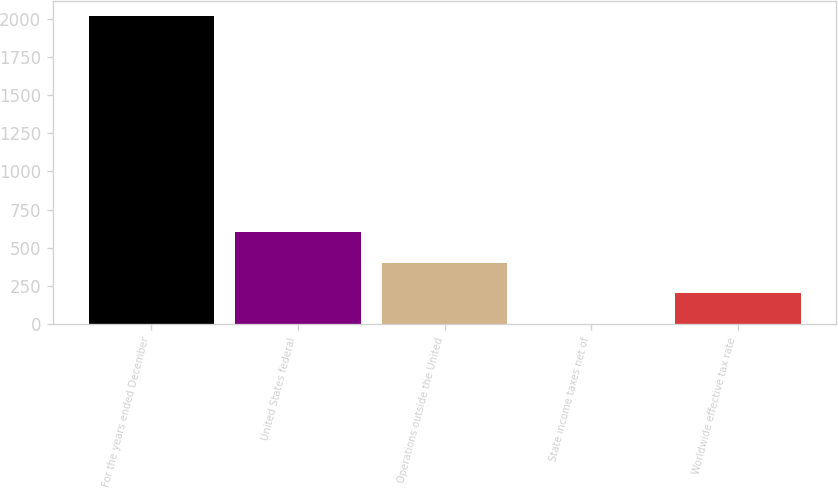Convert chart. <chart><loc_0><loc_0><loc_500><loc_500><bar_chart><fcel>For the years ended December<fcel>United States federal<fcel>Operations outside the United<fcel>State income taxes net of<fcel>Worldwide effective tax rate<nl><fcel>2015<fcel>605.2<fcel>403.8<fcel>1<fcel>202.4<nl></chart> 